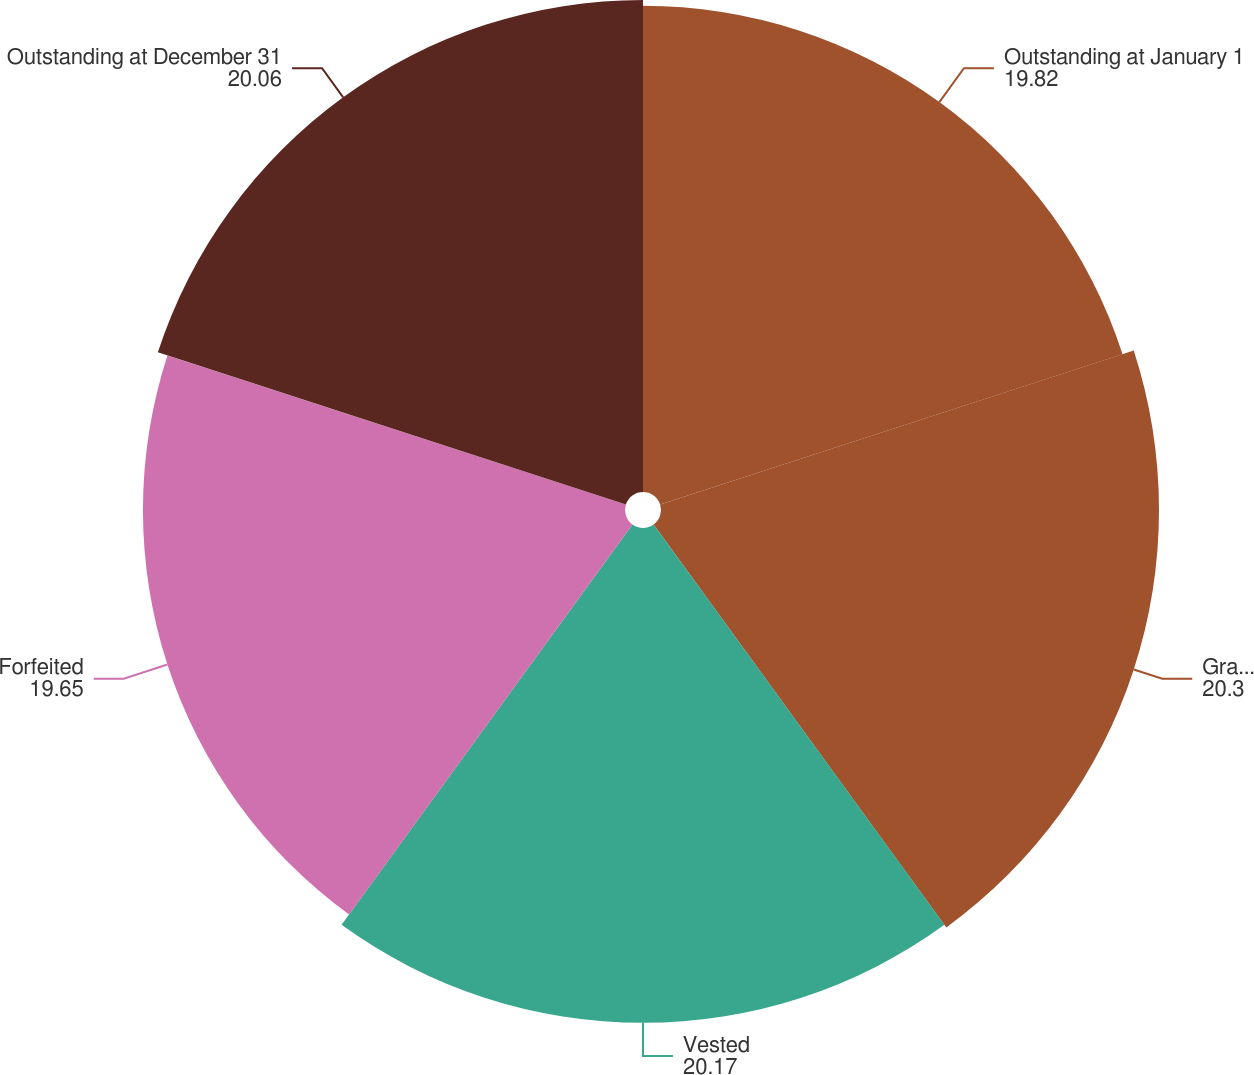Convert chart to OTSL. <chart><loc_0><loc_0><loc_500><loc_500><pie_chart><fcel>Outstanding at January 1<fcel>Granted<fcel>Vested<fcel>Forfeited<fcel>Outstanding at December 31<nl><fcel>19.82%<fcel>20.3%<fcel>20.17%<fcel>19.65%<fcel>20.06%<nl></chart> 